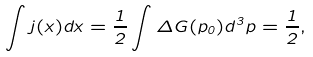<formula> <loc_0><loc_0><loc_500><loc_500>\int j ( x ) d x = \frac { 1 } { 2 } \int \Delta G ( p _ { 0 } ) d ^ { 3 } p = \frac { 1 } { 2 } ,</formula> 